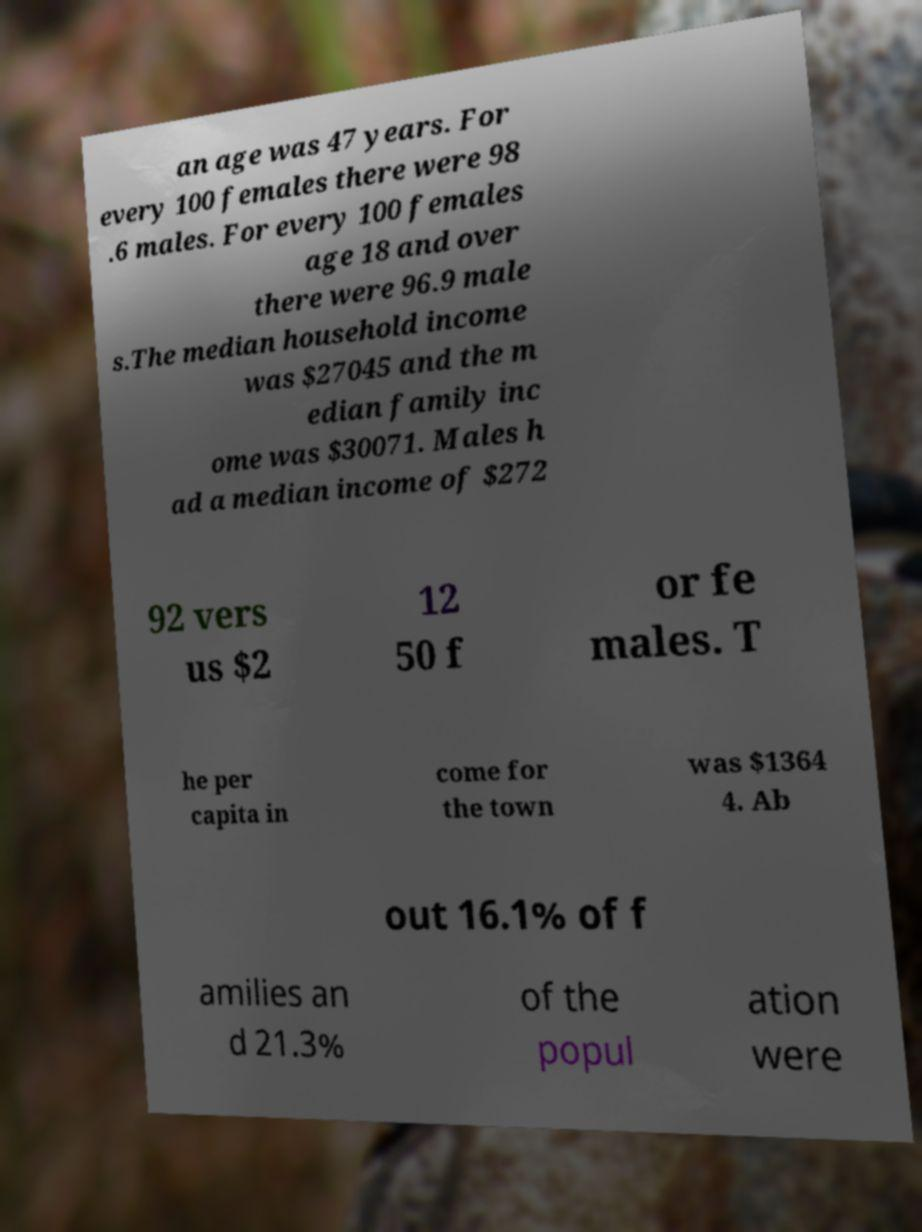What messages or text are displayed in this image? I need them in a readable, typed format. an age was 47 years. For every 100 females there were 98 .6 males. For every 100 females age 18 and over there were 96.9 male s.The median household income was $27045 and the m edian family inc ome was $30071. Males h ad a median income of $272 92 vers us $2 12 50 f or fe males. T he per capita in come for the town was $1364 4. Ab out 16.1% of f amilies an d 21.3% of the popul ation were 